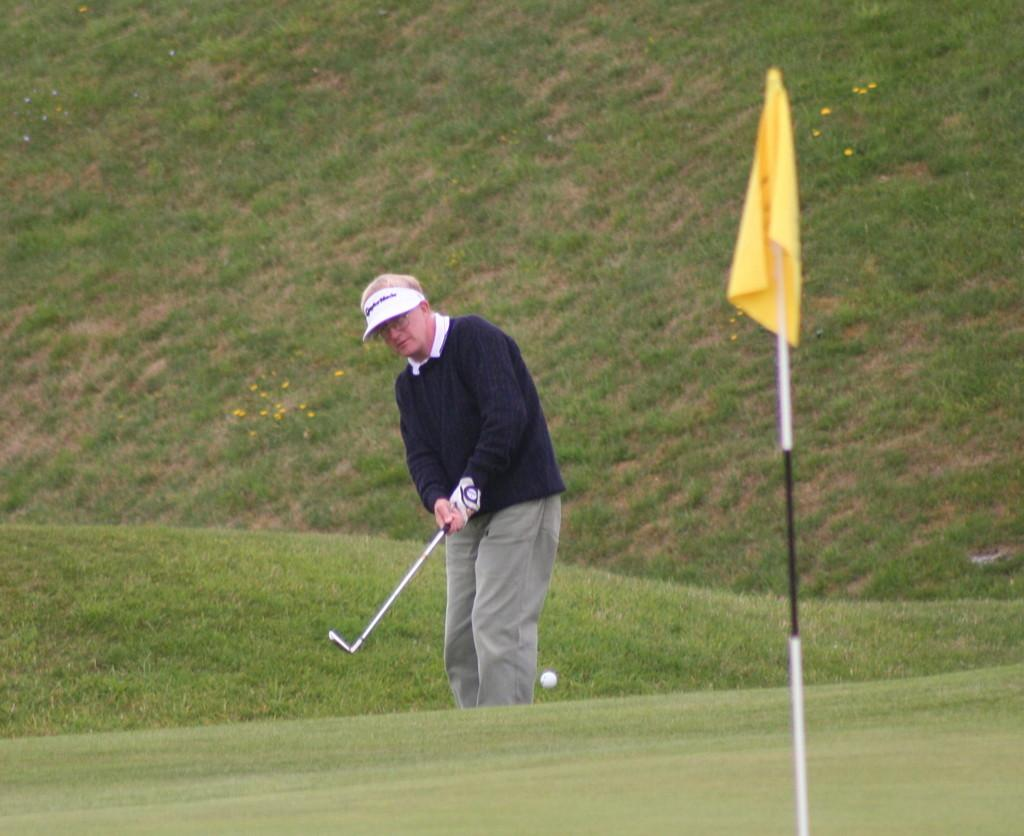What activity is the person in the image engaged in? The person is playing golf in the image. Where is the person playing golf located in the image? The person is in the center of the image. What type of terrain is visible in the image? There is grass in the image. Where is the grass located in the image? The grass is at the bottom of the image. What other object can be seen in the image? There is a flag in the image. What type of manager is overseeing the golf game in the image? There is no manager present in the image; it only shows a person playing golf. How many snails can be seen crawling on the grass in the image? There are no snails visible in the image; it only shows a person playing golf, grass, and a flag. 